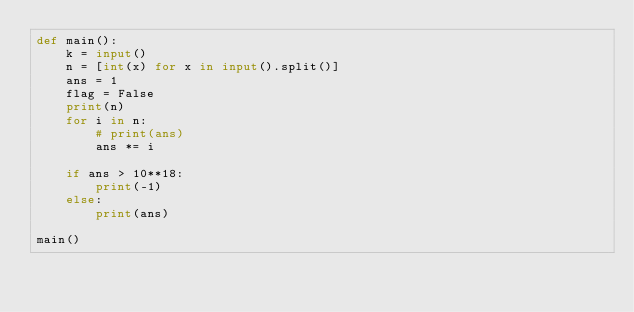Convert code to text. <code><loc_0><loc_0><loc_500><loc_500><_Python_>def main():
    k = input()
    n = [int(x) for x in input().split()]
    ans = 1
    flag = False
    print(n)
    for i in n:
        # print(ans)
        ans *= i

    if ans > 10**18:
        print(-1)
    else:
        print(ans)

main()</code> 